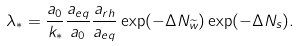<formula> <loc_0><loc_0><loc_500><loc_500>\lambda _ { * } = \frac { a _ { 0 } } { k _ { * } } \frac { a _ { e q } } { a _ { 0 } } \frac { a _ { r h } } { a _ { e q } } \exp ( - \Delta N _ { \widetilde { w } } ) \exp ( - \Delta N _ { s } ) .</formula> 